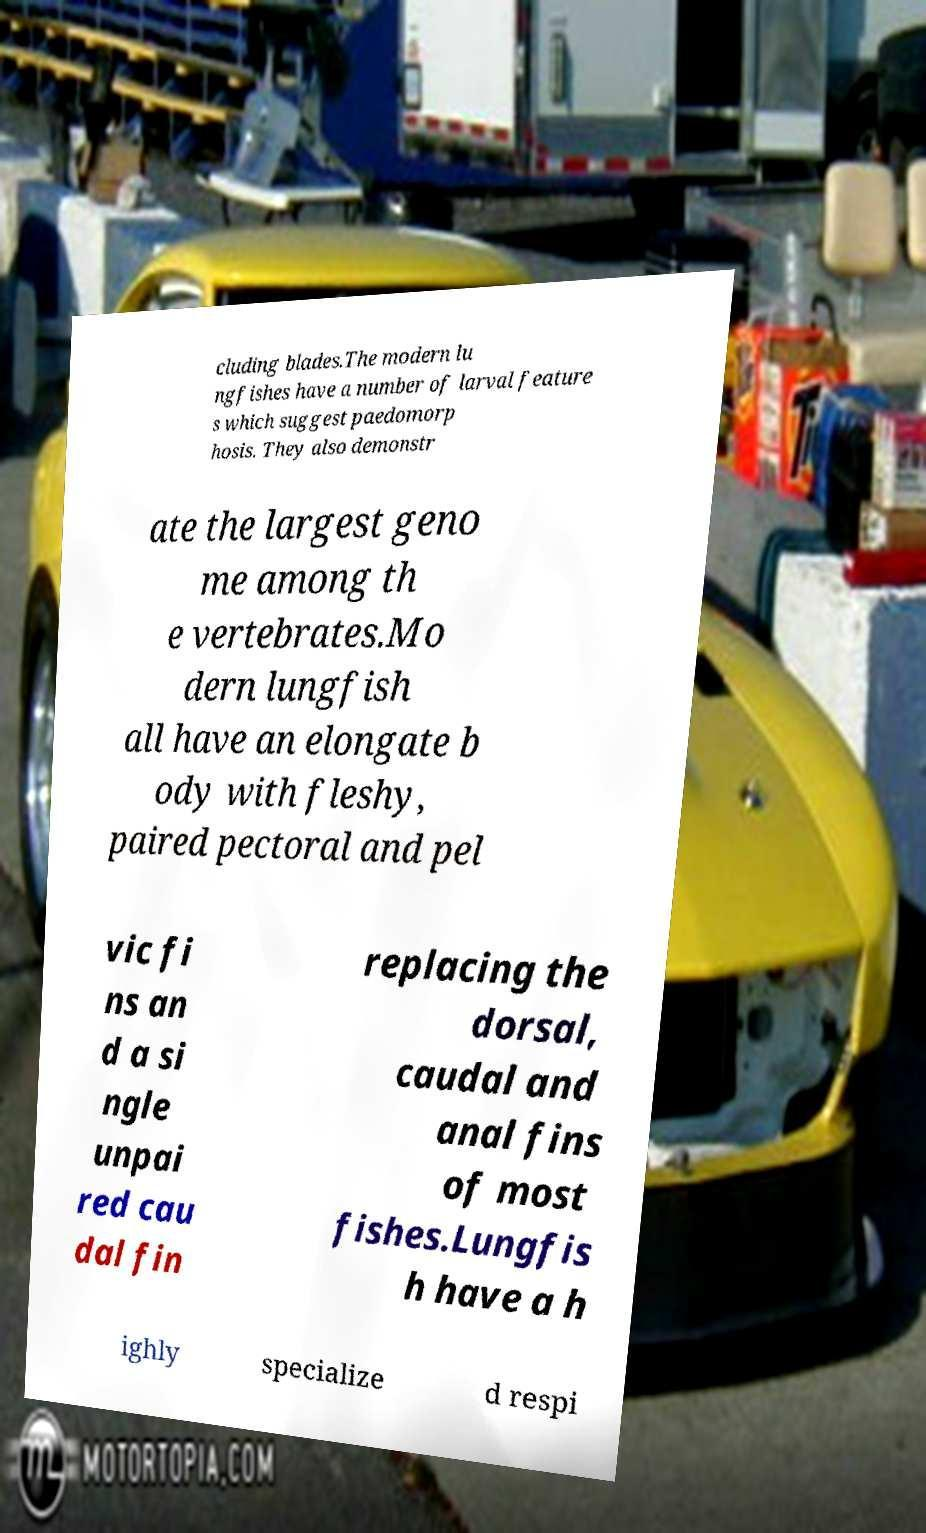Please read and relay the text visible in this image. What does it say? cluding blades.The modern lu ngfishes have a number of larval feature s which suggest paedomorp hosis. They also demonstr ate the largest geno me among th e vertebrates.Mo dern lungfish all have an elongate b ody with fleshy, paired pectoral and pel vic fi ns an d a si ngle unpai red cau dal fin replacing the dorsal, caudal and anal fins of most fishes.Lungfis h have a h ighly specialize d respi 